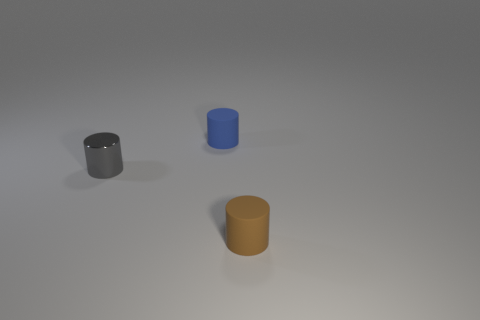Are there fewer brown things that are left of the tiny shiny cylinder than objects to the right of the small brown object?
Provide a succinct answer. No. There is a blue rubber object that is the same shape as the tiny gray thing; what size is it?
Make the answer very short. Small. What number of objects are either tiny matte things that are behind the tiny brown rubber cylinder or things on the right side of the gray shiny thing?
Your answer should be very brief. 2. Is the size of the blue cylinder the same as the gray object?
Offer a terse response. Yes. Is the number of red metal objects greater than the number of blue matte cylinders?
Provide a short and direct response. No. How many other things are there of the same color as the metal object?
Your response must be concise. 0. How many things are tiny rubber objects or red matte spheres?
Offer a very short reply. 2. There is a tiny thing in front of the tiny gray metal cylinder; is its shape the same as the small metallic thing?
Your response must be concise. Yes. There is a tiny thing to the right of the small object behind the small gray thing; what is its color?
Give a very brief answer. Brown. Is the number of tiny blue metallic spheres less than the number of gray shiny objects?
Your answer should be compact. Yes. 